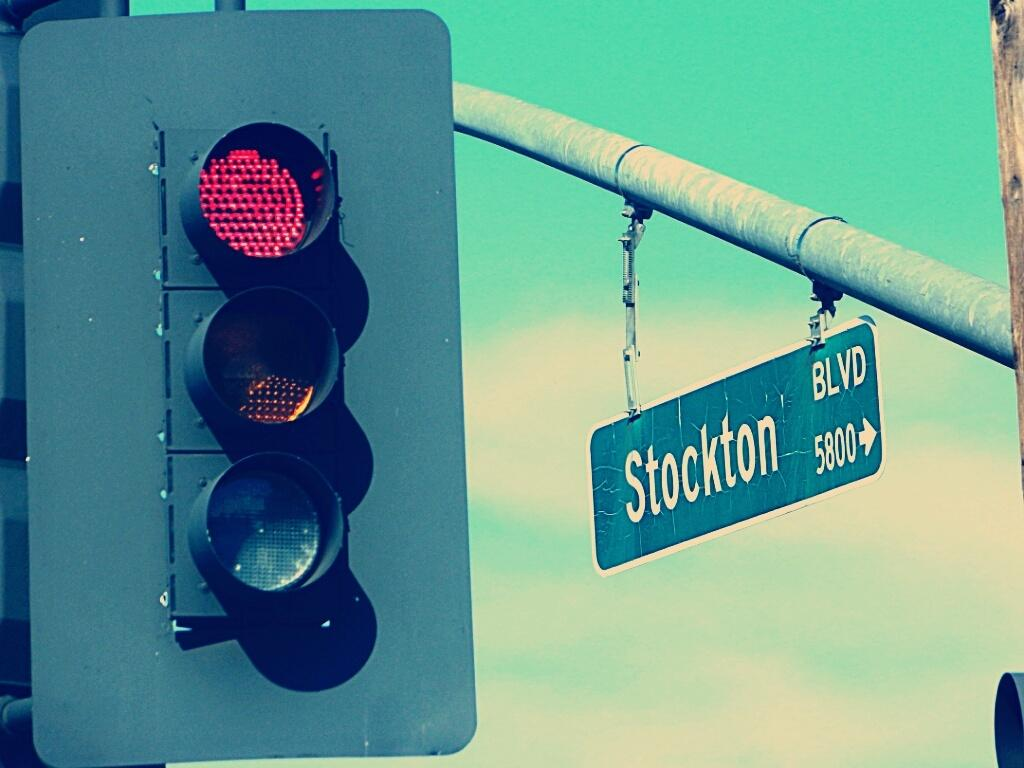<image>
Summarize the visual content of the image. A street sign for Stockton Blvd. hangs near a traffic signal. 